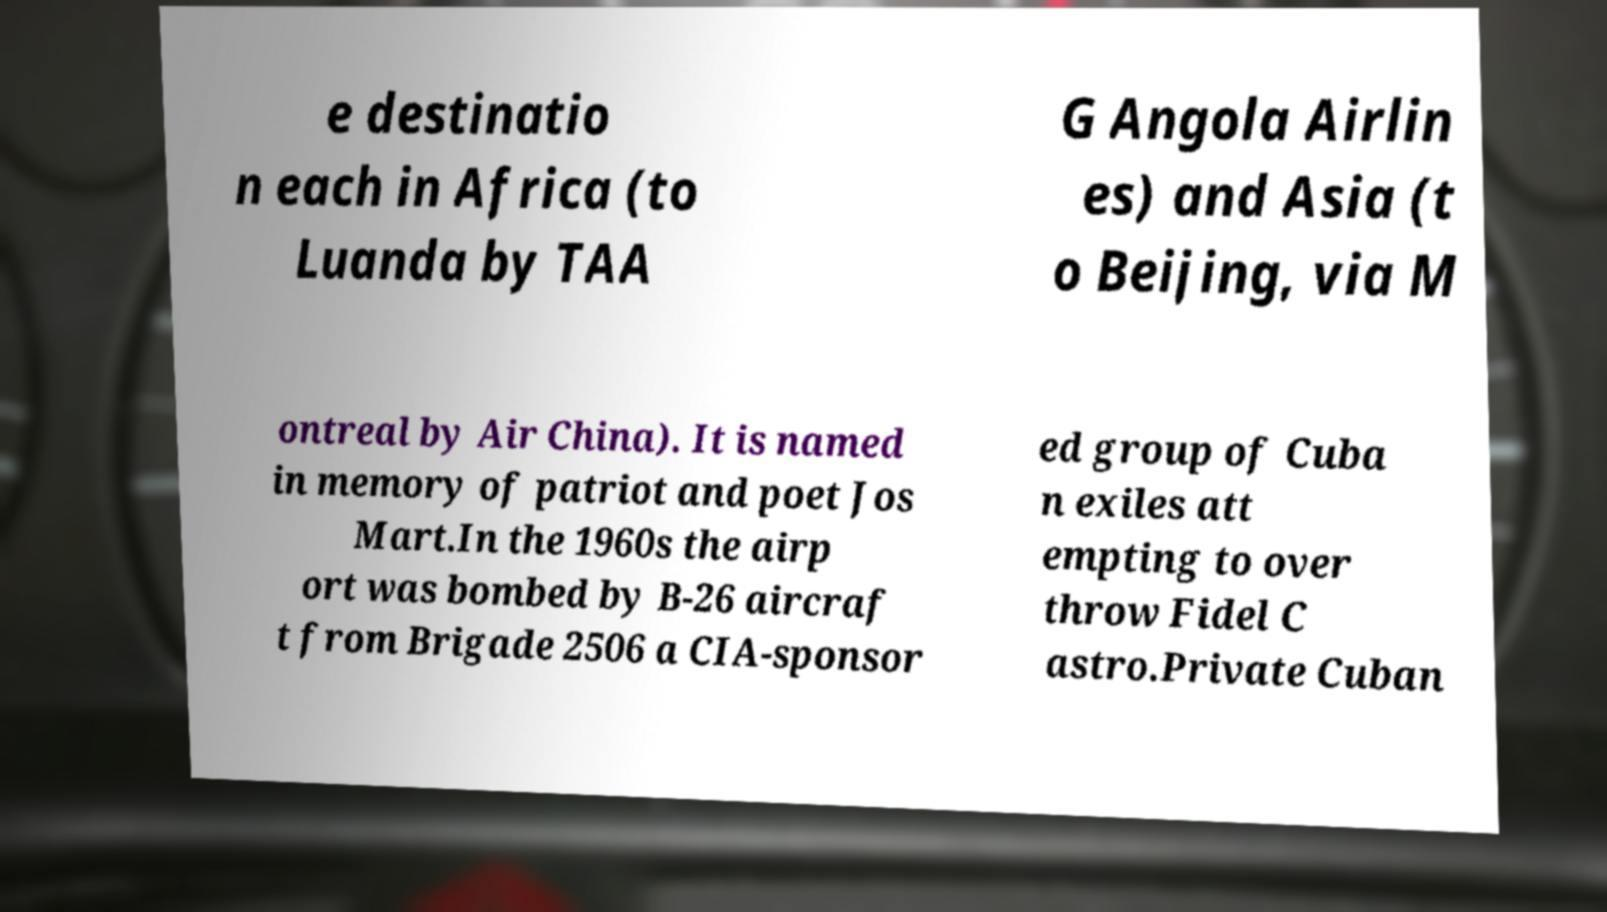Could you assist in decoding the text presented in this image and type it out clearly? e destinatio n each in Africa (to Luanda by TAA G Angola Airlin es) and Asia (t o Beijing, via M ontreal by Air China). It is named in memory of patriot and poet Jos Mart.In the 1960s the airp ort was bombed by B-26 aircraf t from Brigade 2506 a CIA-sponsor ed group of Cuba n exiles att empting to over throw Fidel C astro.Private Cuban 